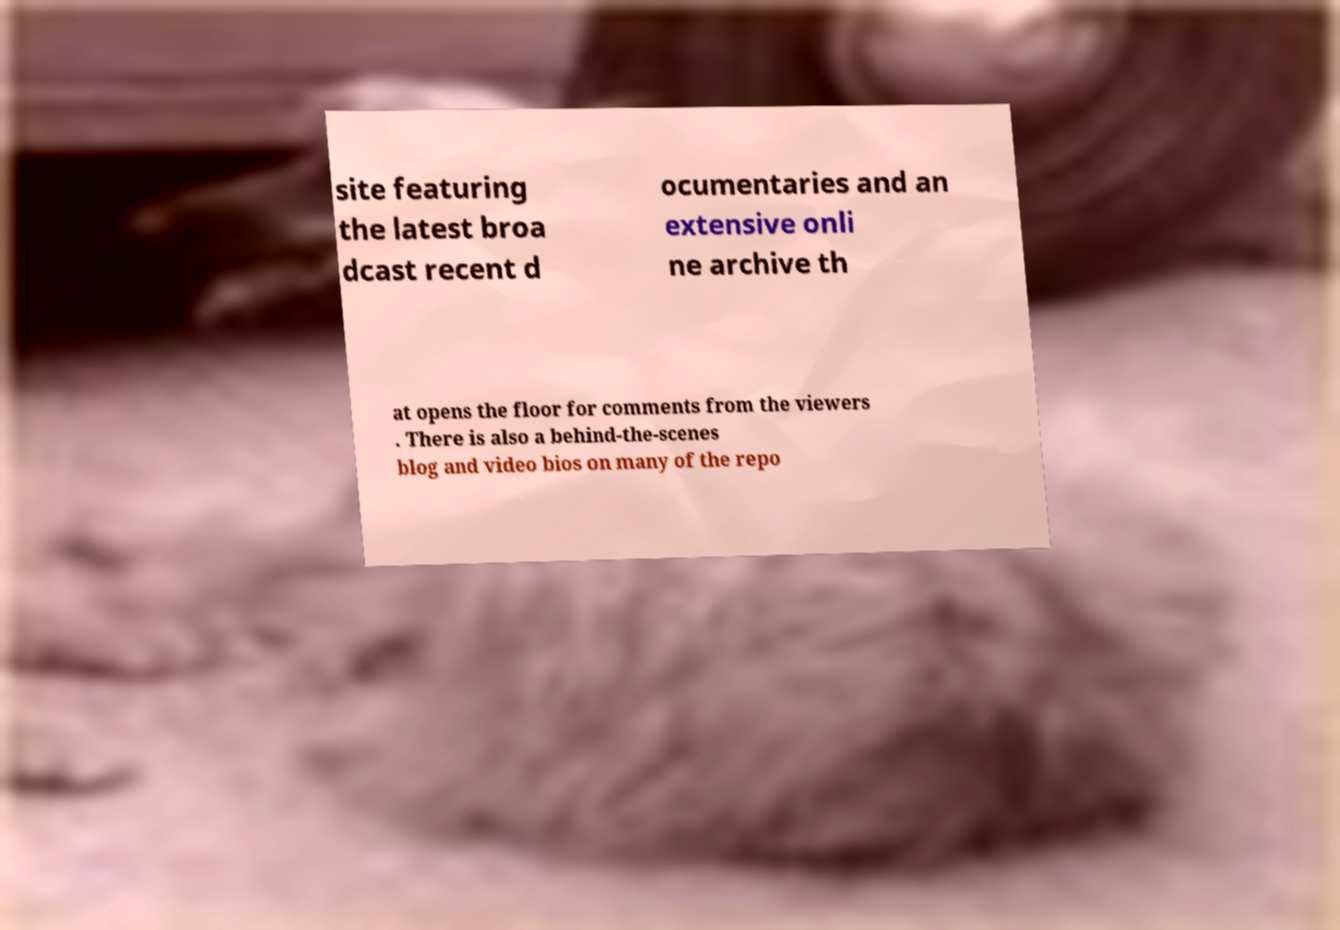Please identify and transcribe the text found in this image. site featuring the latest broa dcast recent d ocumentaries and an extensive onli ne archive th at opens the floor for comments from the viewers . There is also a behind-the-scenes blog and video bios on many of the repo 